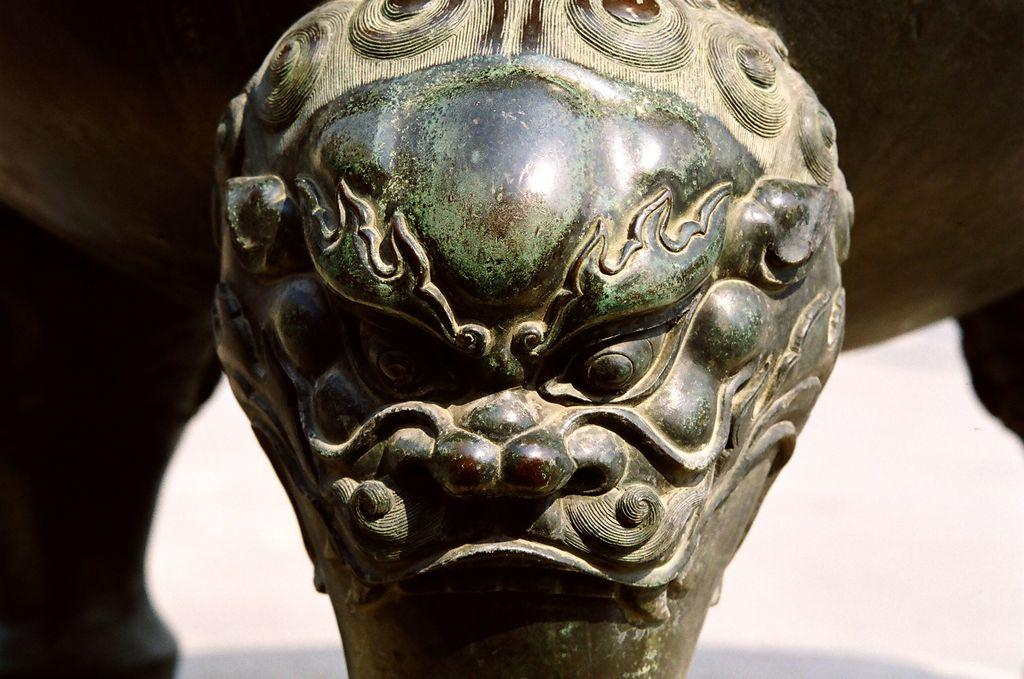What is the main subject of the image? There is a sculpture in the image. What type of power does the rabbit have at the edge of the sculpture? There is no rabbit present in the image, and therefore no power or edge related to a rabbit can be observed. 